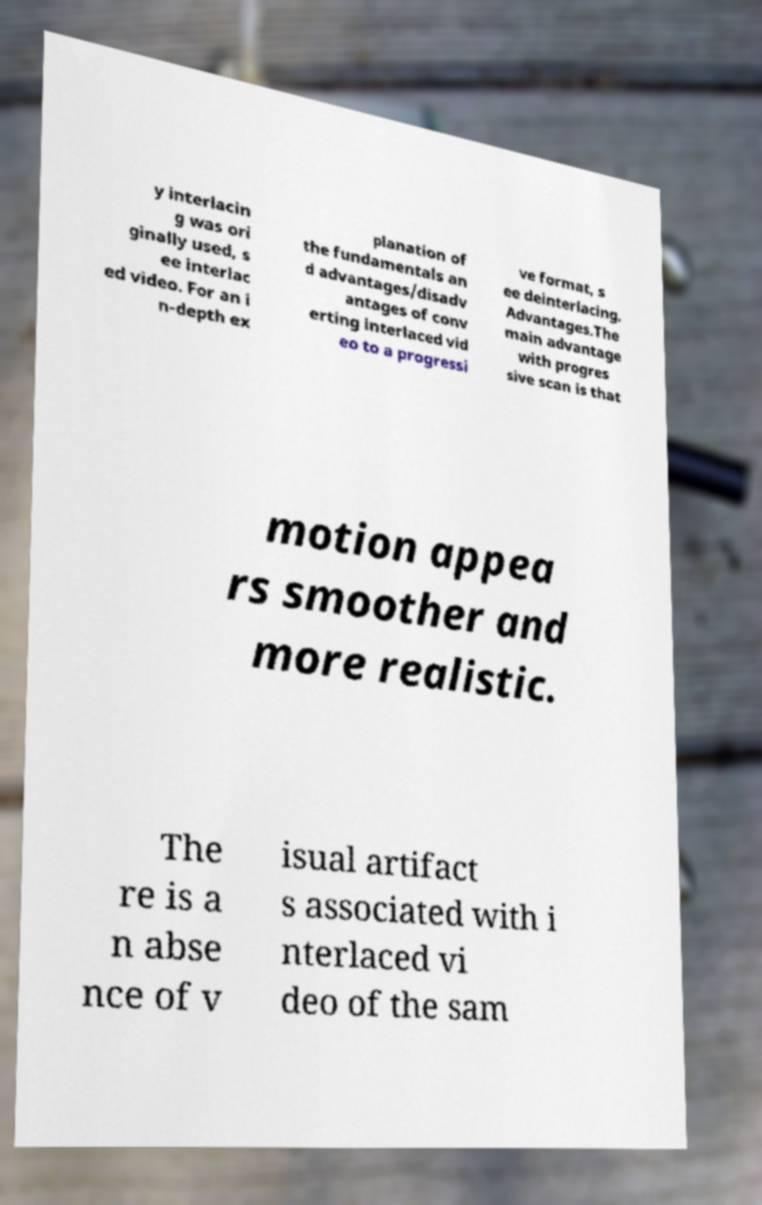Could you extract and type out the text from this image? y interlacin g was ori ginally used, s ee interlac ed video. For an i n-depth ex planation of the fundamentals an d advantages/disadv antages of conv erting interlaced vid eo to a progressi ve format, s ee deinterlacing. Advantages.The main advantage with progres sive scan is that motion appea rs smoother and more realistic. The re is a n abse nce of v isual artifact s associated with i nterlaced vi deo of the sam 